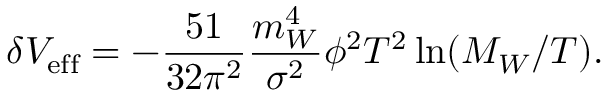Convert formula to latex. <formula><loc_0><loc_0><loc_500><loc_500>\delta V _ { e f f } = - { \frac { 5 1 } { 3 2 \pi ^ { 2 } } } { \frac { m _ { W } ^ { 4 } } { \sigma ^ { 2 } } } \phi ^ { 2 } T ^ { 2 } \ln ( M _ { W } / T ) .</formula> 